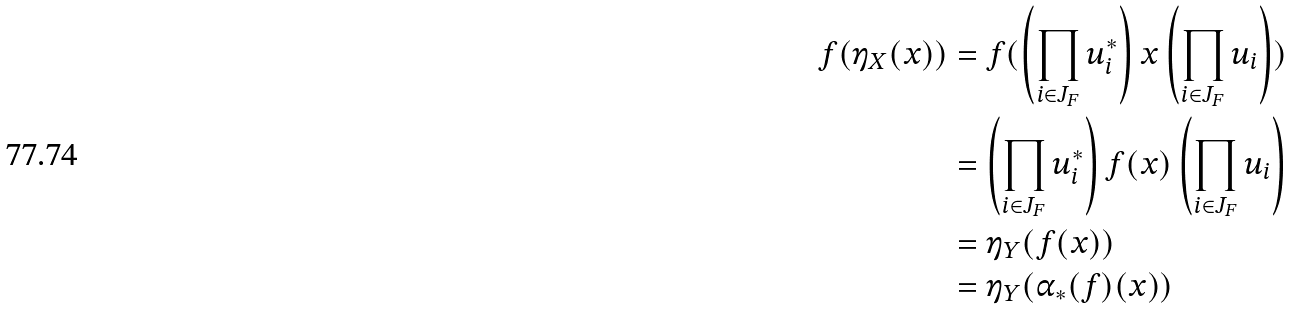Convert formula to latex. <formula><loc_0><loc_0><loc_500><loc_500>f ( \eta _ { X } ( x ) ) & = f ( \left ( \prod _ { i \in J _ { F } } u ^ { * } _ { i } \right ) x \left ( \prod _ { i \in J _ { F } } u _ { i } \right ) ) \\ & = \left ( \prod _ { i \in J _ { F } } u ^ { * } _ { i } \right ) f ( x ) \left ( \prod _ { i \in J _ { F } } u _ { i } \right ) \\ & = \eta _ { Y } ( f ( x ) ) \\ & = \eta _ { Y } ( \alpha _ { * } ( f ) ( x ) ) \\</formula> 